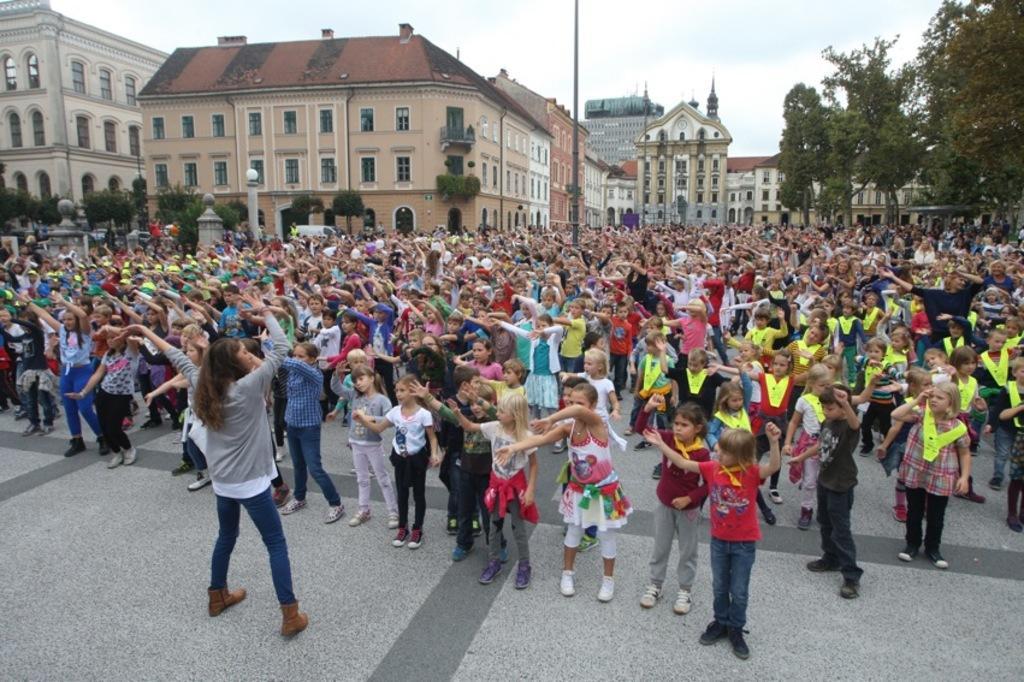How would you summarize this image in a sentence or two? In this image we can see few people standing on the ground and in the background there are few buildings, trees, a pole and the sky. 